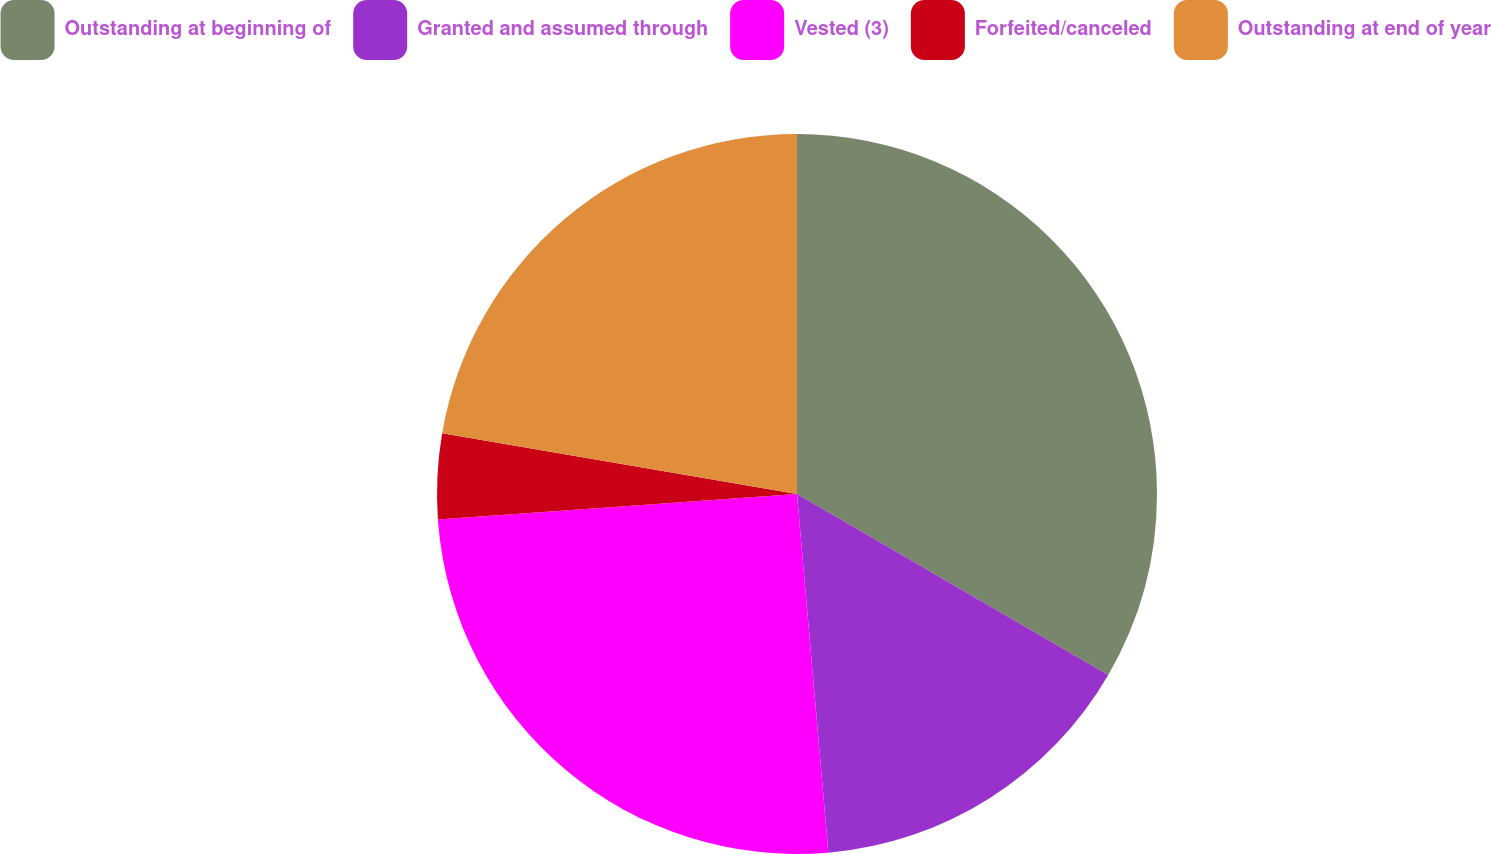Convert chart. <chart><loc_0><loc_0><loc_500><loc_500><pie_chart><fcel>Outstanding at beginning of<fcel>Granted and assumed through<fcel>Vested (3)<fcel>Forfeited/canceled<fcel>Outstanding at end of year<nl><fcel>33.38%<fcel>15.23%<fcel>25.26%<fcel>3.83%<fcel>22.3%<nl></chart> 